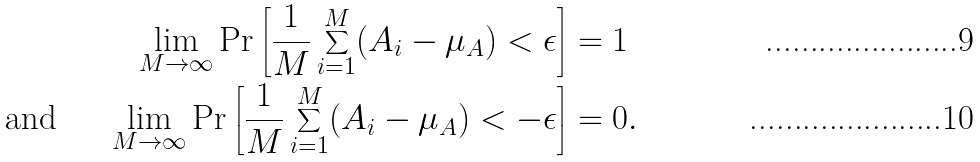Convert formula to latex. <formula><loc_0><loc_0><loc_500><loc_500>& & \lim _ { M \rightarrow \infty } \Pr \left [ \frac { 1 } { M } \sum _ { i = 1 } ^ { M } ( A _ { i } - \mu _ { A } ) < \epsilon \right ] & = 1 & \\ & \text {and} & \lim _ { M \rightarrow \infty } \Pr \left [ \frac { 1 } { M } \sum _ { i = 1 } ^ { M } ( A _ { i } - \mu _ { A } ) < - \epsilon \right ] & = 0 . &</formula> 